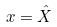Convert formula to latex. <formula><loc_0><loc_0><loc_500><loc_500>x = \hat { X }</formula> 